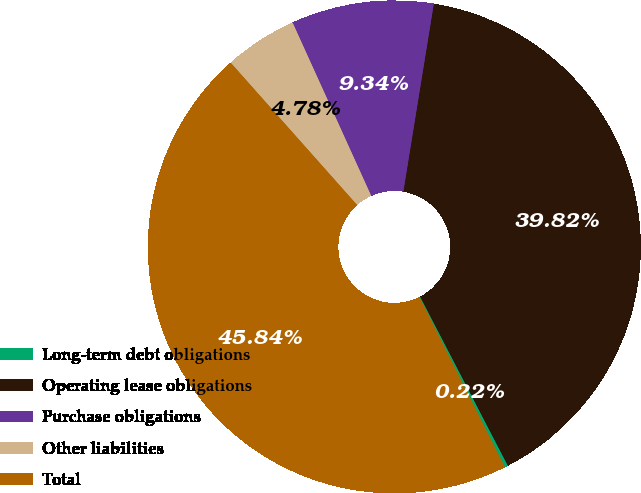Convert chart. <chart><loc_0><loc_0><loc_500><loc_500><pie_chart><fcel>Long-term debt obligations<fcel>Operating lease obligations<fcel>Purchase obligations<fcel>Other liabilities<fcel>Total<nl><fcel>0.22%<fcel>39.82%<fcel>9.34%<fcel>4.78%<fcel>45.84%<nl></chart> 